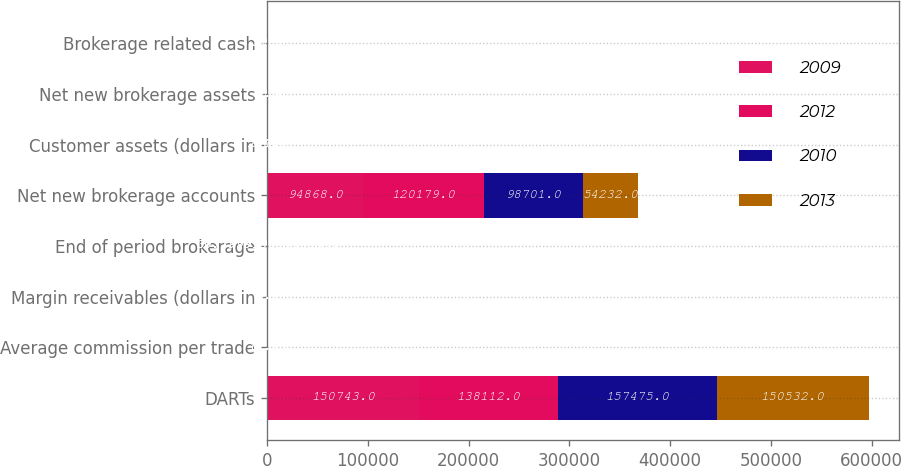<chart> <loc_0><loc_0><loc_500><loc_500><stacked_bar_chart><ecel><fcel>DARTs<fcel>Average commission per trade<fcel>Margin receivables (dollars in<fcel>End of period brokerage<fcel>Net new brokerage accounts<fcel>Customer assets (dollars in<fcel>Net new brokerage assets<fcel>Brokerage related cash<nl><fcel>2009<fcel>150743<fcel>11.13<fcel>6.4<fcel>30.8<fcel>94868<fcel>260.8<fcel>10.4<fcel>39.7<nl><fcel>2012<fcel>138112<fcel>11.01<fcel>5.8<fcel>30.8<fcel>120179<fcel>201.2<fcel>10.4<fcel>33.9<nl><fcel>2010<fcel>157475<fcel>11.01<fcel>4.8<fcel>30.8<fcel>98701<fcel>172.4<fcel>9.7<fcel>27.7<nl><fcel>2013<fcel>150532<fcel>11.21<fcel>5.1<fcel>30.8<fcel>54232<fcel>176.2<fcel>8.1<fcel>24.5<nl></chart> 